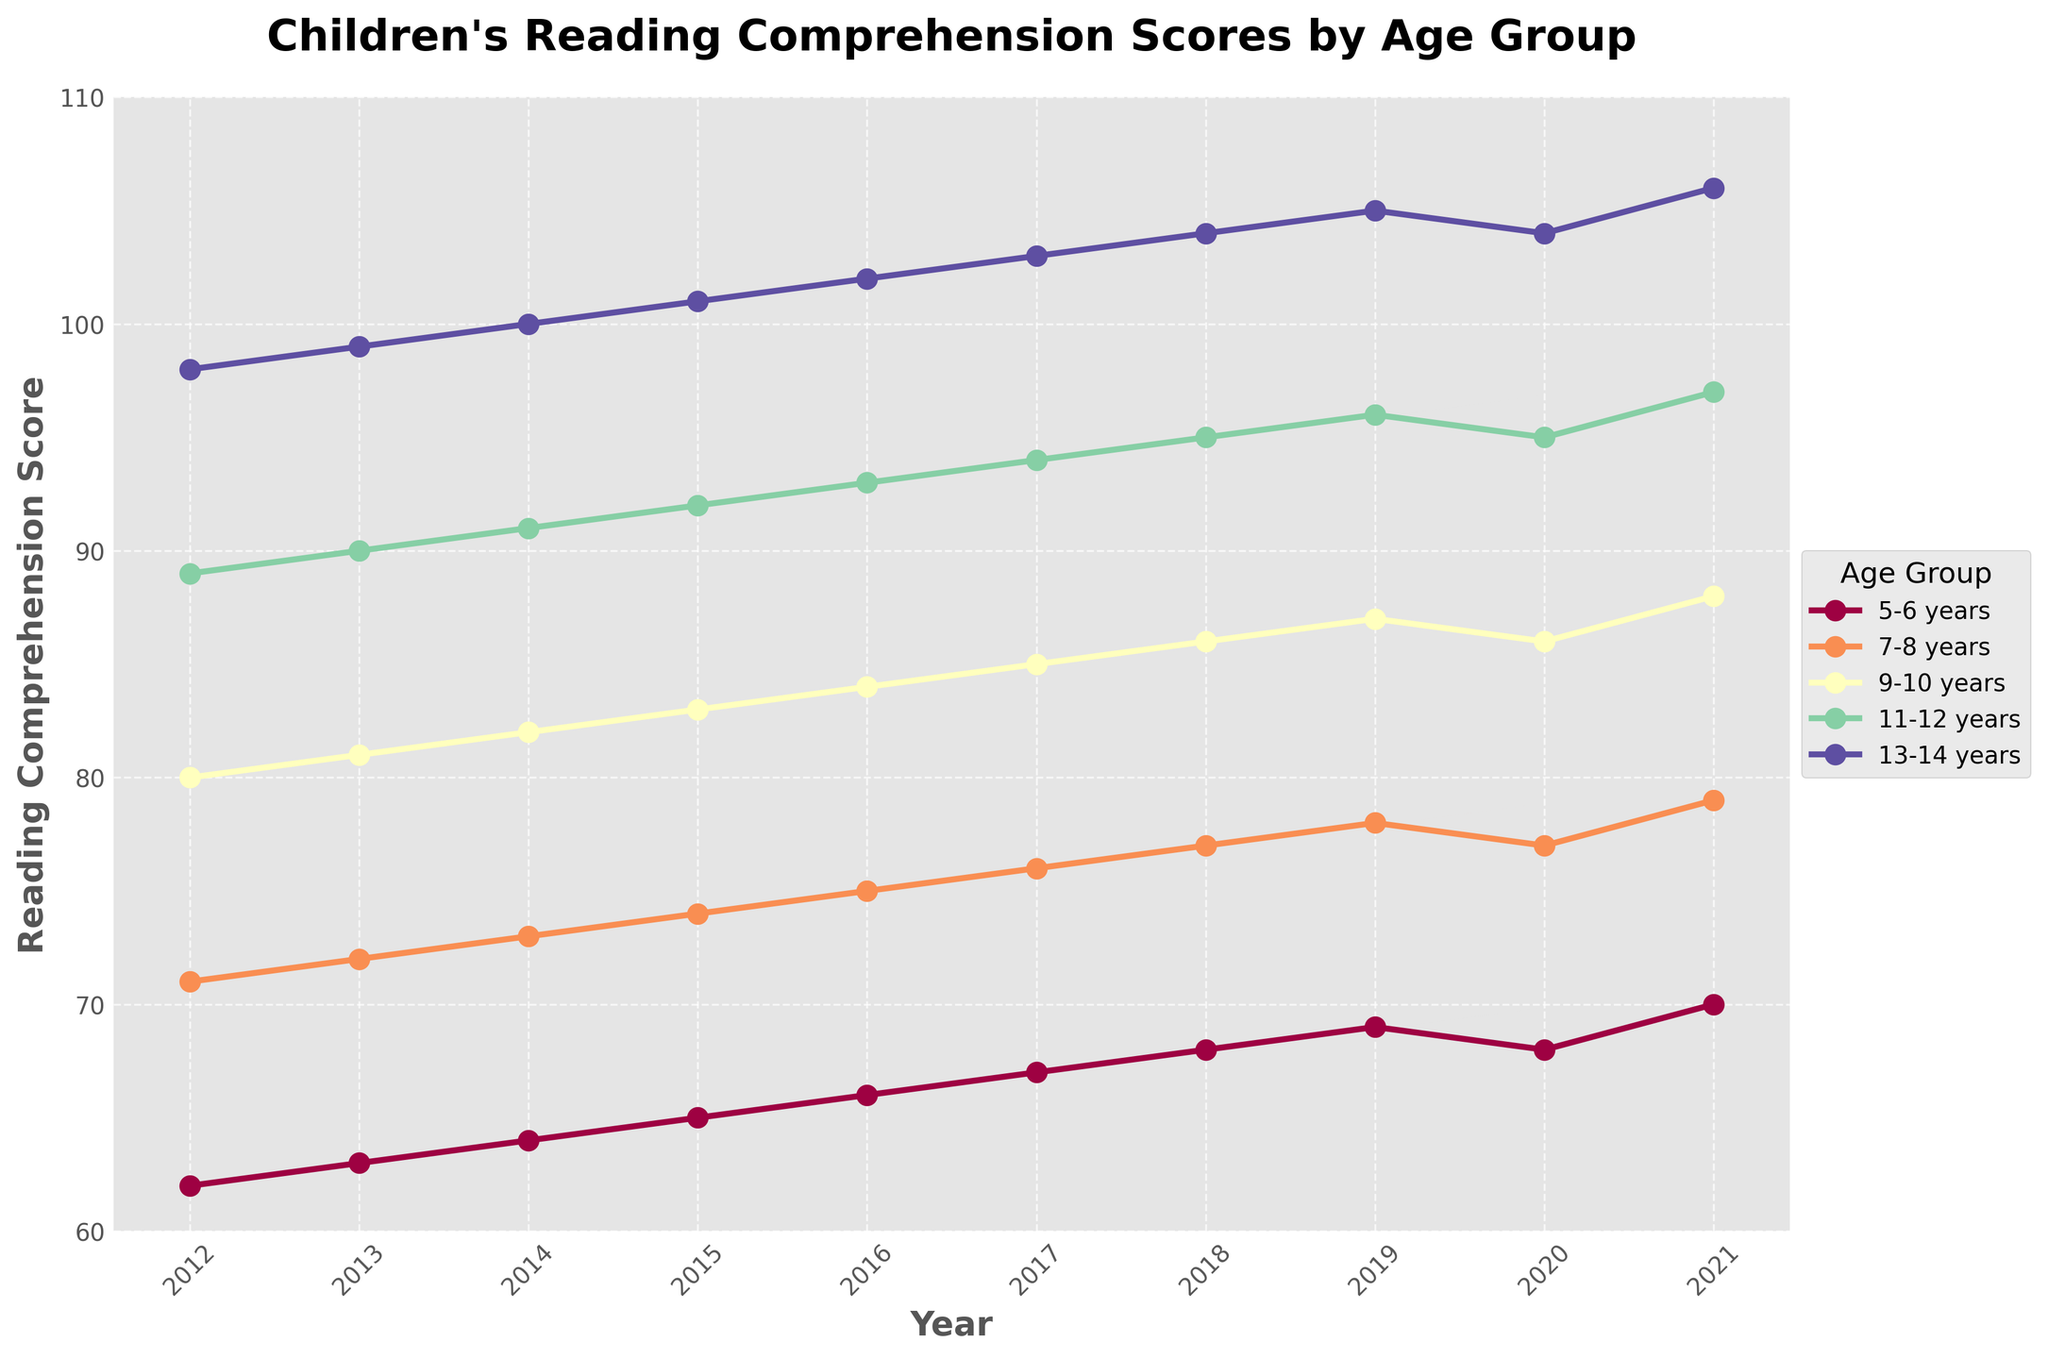What is the trend observed in the reading comprehension scores of the 7-8 years age group from 2012 to 2021? The reading comprehension scores of the 7-8 years age group show an upward trend from 71 in 2012 to 79 in 2021, with a slight dip in 2020 to 77.
Answer: Upward trend Which age group had the highest reading comprehension score in 2021? The age group with the highest value on the vertical axis (reading comprehension score) at the year 2021 is the 13-14 years group with a score of 106.
Answer: 13-14 years What is the difference in reading comprehension scores between the 11-12 years and 5-6 years age groups in 2021? In 2021, the 11-12 years group's score is 97, while the 5-6 years group is 70. The difference is 97 - 70.
Answer: 27 Which age group showed the smallest increase in reading comprehension scores from 2012 to 2021? By comparing the scores of all age groups from 2012 to 2021, the 13-14 years group increased from 98 to 106, which is an increase of 8, this is the smallest increase observed.
Answer: 13-14 years What is the average reading comprehension score for the 9-10 years age group over the decade? The scores from 2012 to 2021 for the 9-10 years age group are 80, 81, 82, 83, 84, 85, 86, 87, 86, and 88. The sum is 842, and there are 10 data points. Average is 842/10.
Answer: 84.2 Compare the reading comprehension score trend of the 5-6 years and 9-10 years age groups from 2019 to 2021. What are the notable differences? From 2019 to 2021, the 5-6 years group went from 69 to 70 with a dip to 68 in 2020, while the 9-10 years group went from 87 to 88 with a dip to 86 in 2020. The notable difference is the higher overall scores and the sharper rebound from the dip for the 9-10 years group.
Answer: Higher overall scores and sharper rebound for 9-10 years Which age group consistently shows the highest scores over the entire period? By looking at all years from 2012 to 2021, the age group that consistently has the highest scores each year is the 13-14 years group.
Answer: 13-14 years How did the COVID-19 pandemic affect the reading comprehension scores in 2020 across different age groups? In 2020, there is a visible dip in the scores for all age groups compared to the previous year, indicating a possible negative impact from the pandemic.
Answer: Negative impact with a dip in scores across all groups 